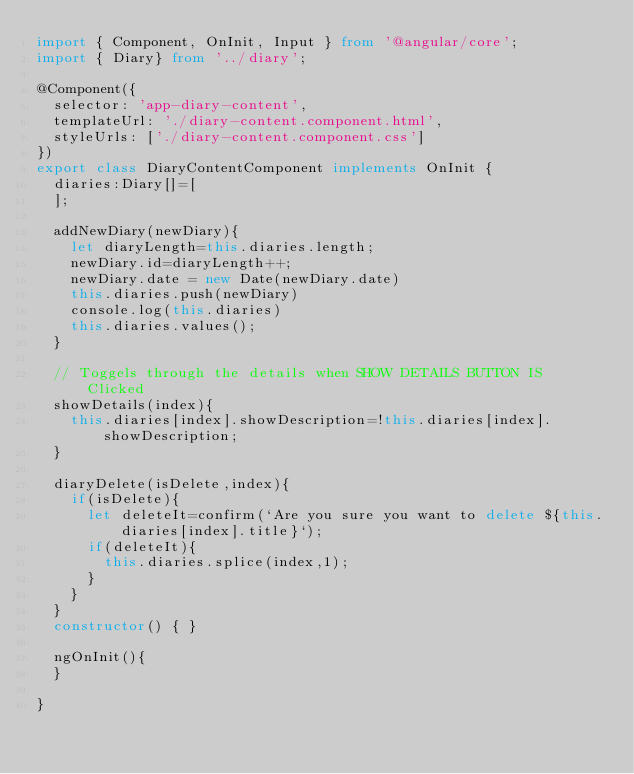<code> <loc_0><loc_0><loc_500><loc_500><_TypeScript_>import { Component, OnInit, Input } from '@angular/core';
import { Diary} from '../diary';

@Component({
  selector: 'app-diary-content',
  templateUrl: './diary-content.component.html',
  styleUrls: ['./diary-content.component.css']
})
export class DiaryContentComponent implements OnInit {
  diaries:Diary[]=[
  ];

  addNewDiary(newDiary){
    let diaryLength=this.diaries.length;
    newDiary.id=diaryLength++;
    newDiary.date = new Date(newDiary.date)
    this.diaries.push(newDiary)
    console.log(this.diaries)
    this.diaries.values();
  }

  // Toggels through the details when SHOW DETAILS BUTTON IS Clicked
  showDetails(index){
    this.diaries[index].showDescription=!this.diaries[index].showDescription;
  }
  
  diaryDelete(isDelete,index){
    if(isDelete){
      let deleteIt=confirm(`Are you sure you want to delete ${this.diaries[index].title}`);
      if(deleteIt){
        this.diaries.splice(index,1);
      }
    }
  }
  constructor() { }

  ngOnInit(){
  }

}
</code> 